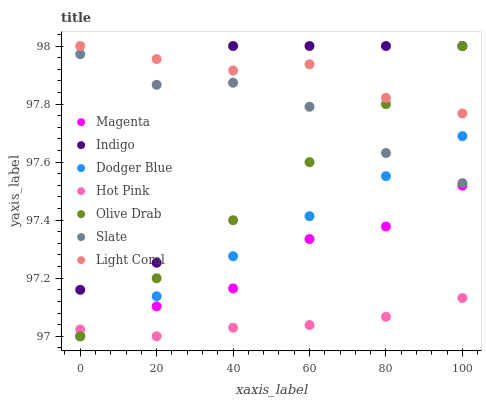Does Hot Pink have the minimum area under the curve?
Answer yes or no. Yes. Does Light Coral have the maximum area under the curve?
Answer yes or no. Yes. Does Slate have the minimum area under the curve?
Answer yes or no. No. Does Slate have the maximum area under the curve?
Answer yes or no. No. Is Dodger Blue the smoothest?
Answer yes or no. Yes. Is Indigo the roughest?
Answer yes or no. Yes. Is Slate the smoothest?
Answer yes or no. No. Is Slate the roughest?
Answer yes or no. No. Does Hot Pink have the lowest value?
Answer yes or no. Yes. Does Slate have the lowest value?
Answer yes or no. No. Does Light Coral have the highest value?
Answer yes or no. Yes. Does Slate have the highest value?
Answer yes or no. No. Is Olive Drab less than Indigo?
Answer yes or no. Yes. Is Light Coral greater than Dodger Blue?
Answer yes or no. Yes. Does Hot Pink intersect Dodger Blue?
Answer yes or no. Yes. Is Hot Pink less than Dodger Blue?
Answer yes or no. No. Is Hot Pink greater than Dodger Blue?
Answer yes or no. No. Does Olive Drab intersect Indigo?
Answer yes or no. No. 